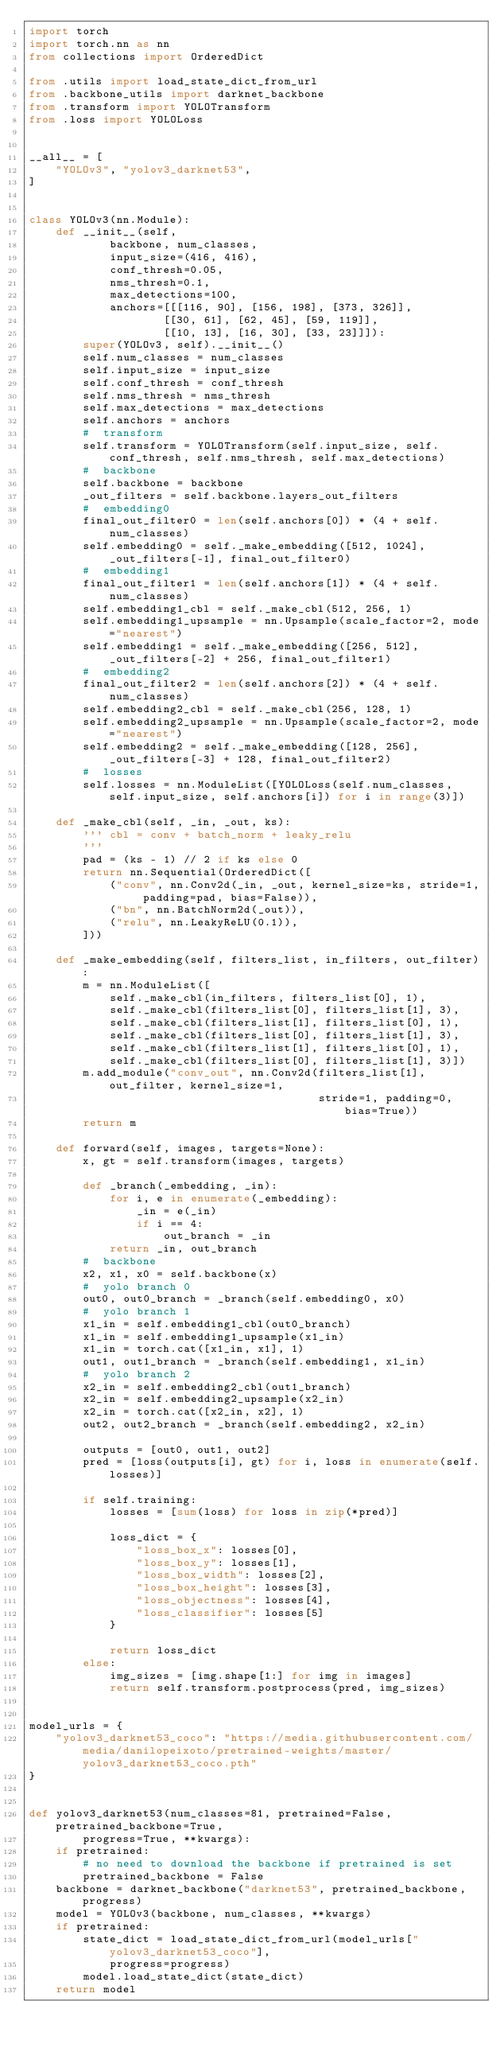<code> <loc_0><loc_0><loc_500><loc_500><_Python_>import torch
import torch.nn as nn
from collections import OrderedDict

from .utils import load_state_dict_from_url
from .backbone_utils import darknet_backbone
from .transform import YOLOTransform
from .loss import YOLOLoss


__all__ = [
    "YOLOv3", "yolov3_darknet53",
]


class YOLOv3(nn.Module):
    def __init__(self,
            backbone, num_classes,
            input_size=(416, 416),
            conf_thresh=0.05,
            nms_thresh=0.1,
            max_detections=100,
            anchors=[[[116, 90], [156, 198], [373, 326]],
                    [[30, 61], [62, 45], [59, 119]],
                    [[10, 13], [16, 30], [33, 23]]]):
        super(YOLOv3, self).__init__()
        self.num_classes = num_classes
        self.input_size = input_size
        self.conf_thresh = conf_thresh
        self.nms_thresh = nms_thresh
        self.max_detections = max_detections
        self.anchors = anchors
        #  transform
        self.transform = YOLOTransform(self.input_size, self.conf_thresh, self.nms_thresh, self.max_detections)
        #  backbone
        self.backbone = backbone
        _out_filters = self.backbone.layers_out_filters
        #  embedding0
        final_out_filter0 = len(self.anchors[0]) * (4 + self.num_classes)
        self.embedding0 = self._make_embedding([512, 1024], _out_filters[-1], final_out_filter0)
        #  embedding1
        final_out_filter1 = len(self.anchors[1]) * (4 + self.num_classes)
        self.embedding1_cbl = self._make_cbl(512, 256, 1)
        self.embedding1_upsample = nn.Upsample(scale_factor=2, mode="nearest")
        self.embedding1 = self._make_embedding([256, 512], _out_filters[-2] + 256, final_out_filter1)
        #  embedding2
        final_out_filter2 = len(self.anchors[2]) * (4 + self.num_classes)
        self.embedding2_cbl = self._make_cbl(256, 128, 1)
        self.embedding2_upsample = nn.Upsample(scale_factor=2, mode="nearest")
        self.embedding2 = self._make_embedding([128, 256], _out_filters[-3] + 128, final_out_filter2)
        #  losses
        self.losses = nn.ModuleList([YOLOLoss(self.num_classes, self.input_size, self.anchors[i]) for i in range(3)])

    def _make_cbl(self, _in, _out, ks):
        ''' cbl = conv + batch_norm + leaky_relu
        '''
        pad = (ks - 1) // 2 if ks else 0
        return nn.Sequential(OrderedDict([
            ("conv", nn.Conv2d(_in, _out, kernel_size=ks, stride=1, padding=pad, bias=False)),
            ("bn", nn.BatchNorm2d(_out)),
            ("relu", nn.LeakyReLU(0.1)),
        ]))

    def _make_embedding(self, filters_list, in_filters, out_filter):
        m = nn.ModuleList([
            self._make_cbl(in_filters, filters_list[0], 1),
            self._make_cbl(filters_list[0], filters_list[1], 3),
            self._make_cbl(filters_list[1], filters_list[0], 1),
            self._make_cbl(filters_list[0], filters_list[1], 3),
            self._make_cbl(filters_list[1], filters_list[0], 1),
            self._make_cbl(filters_list[0], filters_list[1], 3)])
        m.add_module("conv_out", nn.Conv2d(filters_list[1], out_filter, kernel_size=1,
                                           stride=1, padding=0, bias=True))
        return m

    def forward(self, images, targets=None):
        x, gt = self.transform(images, targets)
        
        def _branch(_embedding, _in):
            for i, e in enumerate(_embedding):
                _in = e(_in)
                if i == 4:
                    out_branch = _in
            return _in, out_branch
        #  backbone
        x2, x1, x0 = self.backbone(x)
        #  yolo branch 0
        out0, out0_branch = _branch(self.embedding0, x0)
        #  yolo branch 1
        x1_in = self.embedding1_cbl(out0_branch)
        x1_in = self.embedding1_upsample(x1_in)
        x1_in = torch.cat([x1_in, x1], 1)
        out1, out1_branch = _branch(self.embedding1, x1_in)
        #  yolo branch 2
        x2_in = self.embedding2_cbl(out1_branch)
        x2_in = self.embedding2_upsample(x2_in)
        x2_in = torch.cat([x2_in, x2], 1)
        out2, out2_branch = _branch(self.embedding2, x2_in)

        outputs = [out0, out1, out2]
        pred = [loss(outputs[i], gt) for i, loss in enumerate(self.losses)]
        
        if self.training:
            losses = [sum(loss) for loss in zip(*pred)]

            loss_dict = {
                "loss_box_x": losses[0],
                "loss_box_y": losses[1],
                "loss_box_width": losses[2],
                "loss_box_height": losses[3],
                "loss_objectness": losses[4],
                "loss_classifier": losses[5]
            }

            return loss_dict
        else:
            img_sizes = [img.shape[1:] for img in images]
            return self.transform.postprocess(pred, img_sizes)


model_urls = {
    "yolov3_darknet53_coco": "https://media.githubusercontent.com/media/danilopeixoto/pretrained-weights/master/yolov3_darknet53_coco.pth"
}


def yolov3_darknet53(num_classes=81, pretrained=False, pretrained_backbone=True,
        progress=True, **kwargs):
    if pretrained:
        # no need to download the backbone if pretrained is set
        pretrained_backbone = False
    backbone = darknet_backbone("darknet53", pretrained_backbone, progress)
    model = YOLOv3(backbone, num_classes, **kwargs)
    if pretrained:
        state_dict = load_state_dict_from_url(model_urls["yolov3_darknet53_coco"],
            progress=progress)
        model.load_state_dict(state_dict)
    return model
</code> 